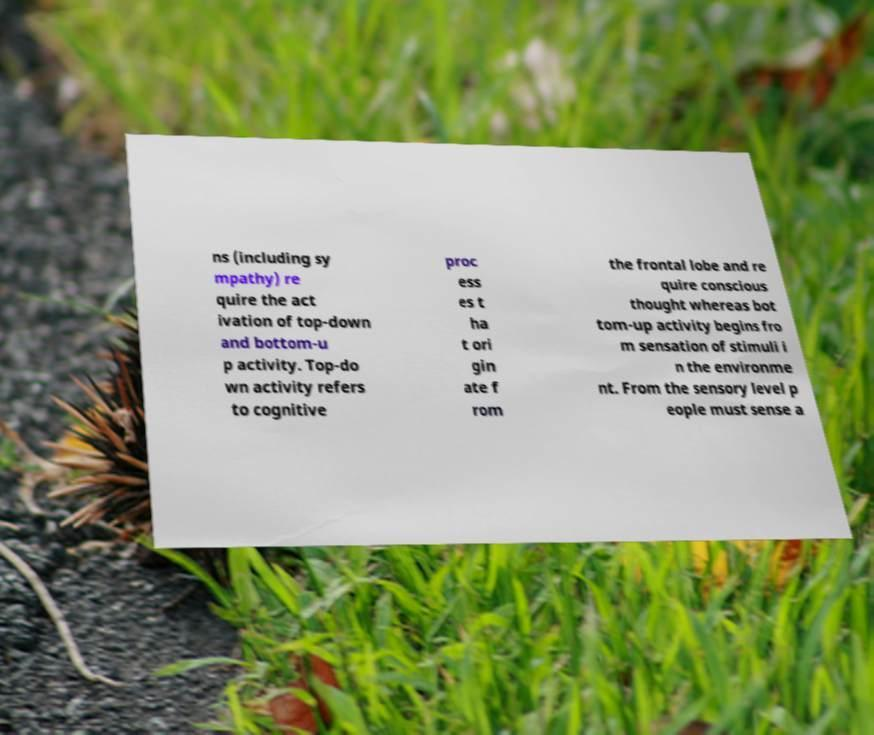Please read and relay the text visible in this image. What does it say? ns (including sy mpathy) re quire the act ivation of top-down and bottom-u p activity. Top-do wn activity refers to cognitive proc ess es t ha t ori gin ate f rom the frontal lobe and re quire conscious thought whereas bot tom-up activity begins fro m sensation of stimuli i n the environme nt. From the sensory level p eople must sense a 